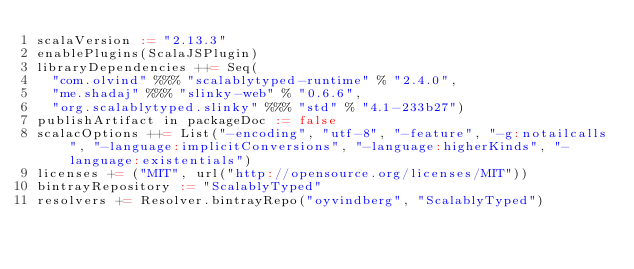<code> <loc_0><loc_0><loc_500><loc_500><_Scala_>scalaVersion := "2.13.3"
enablePlugins(ScalaJSPlugin)
libraryDependencies ++= Seq(
  "com.olvind" %%% "scalablytyped-runtime" % "2.4.0",
  "me.shadaj" %%% "slinky-web" % "0.6.6",
  "org.scalablytyped.slinky" %%% "std" % "4.1-233b27")
publishArtifact in packageDoc := false
scalacOptions ++= List("-encoding", "utf-8", "-feature", "-g:notailcalls", "-language:implicitConversions", "-language:higherKinds", "-language:existentials")
licenses += ("MIT", url("http://opensource.org/licenses/MIT"))
bintrayRepository := "ScalablyTyped"
resolvers += Resolver.bintrayRepo("oyvindberg", "ScalablyTyped")
</code> 